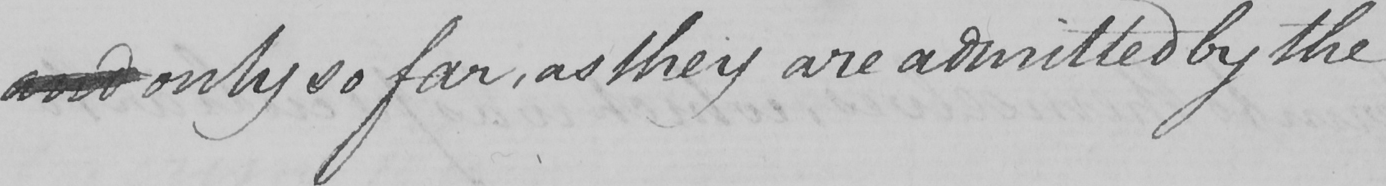Can you tell me what this handwritten text says? and only so far , as they are admitted by the 